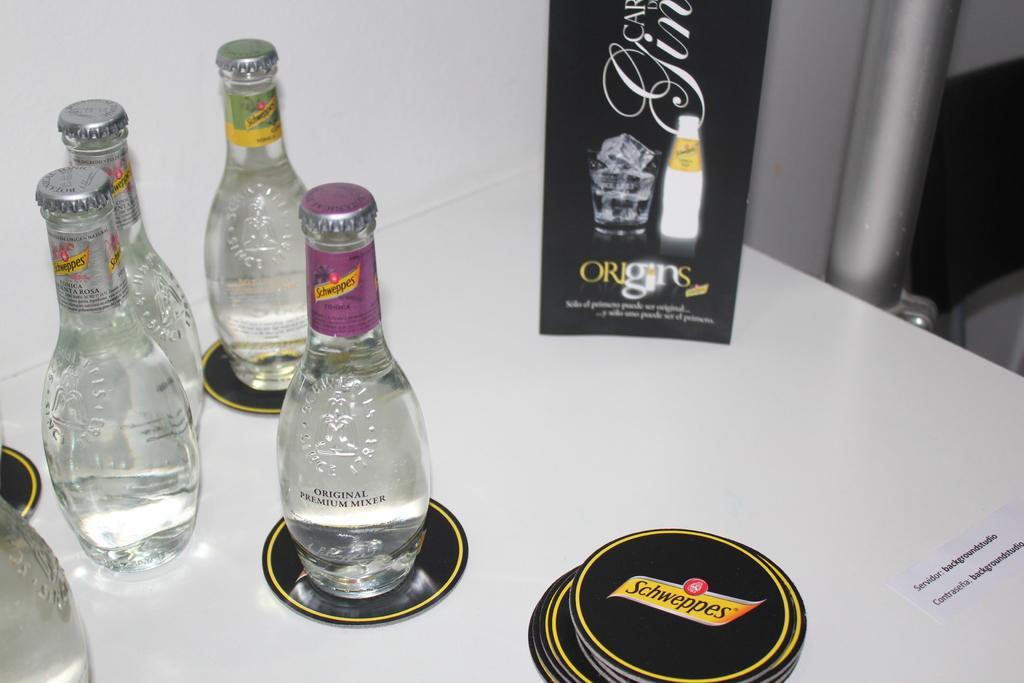Could you give a brief overview of what you see in this image? These are the Bottles with some liquids in it. In the right there is a name origin with pictures in it. 